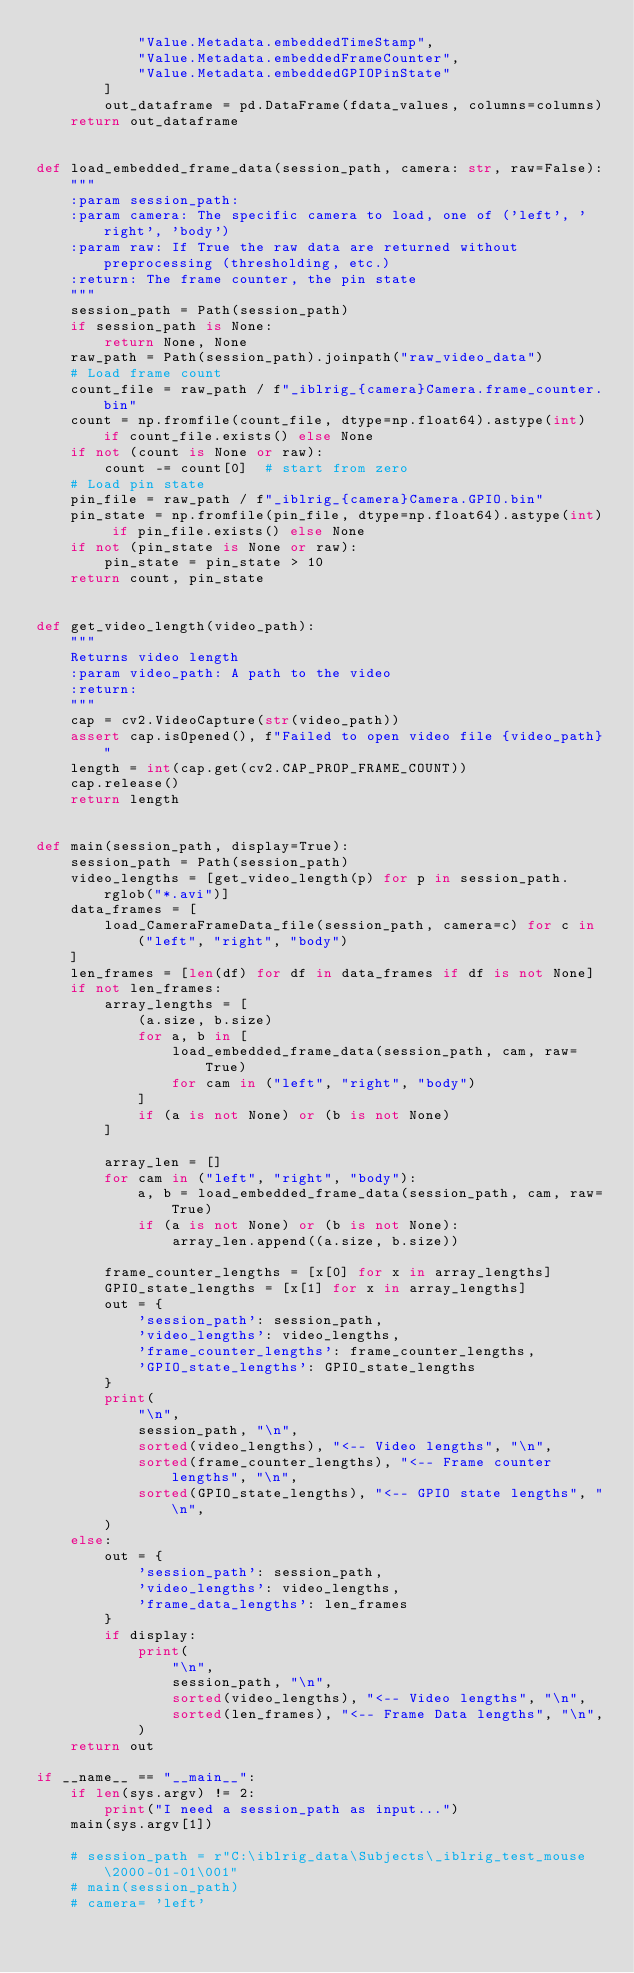<code> <loc_0><loc_0><loc_500><loc_500><_Python_>            "Value.Metadata.embeddedTimeStamp",
            "Value.Metadata.embeddedFrameCounter",
            "Value.Metadata.embeddedGPIOPinState"
        ]
        out_dataframe = pd.DataFrame(fdata_values, columns=columns)
    return out_dataframe


def load_embedded_frame_data(session_path, camera: str, raw=False):
    """
    :param session_path:
    :param camera: The specific camera to load, one of ('left', 'right', 'body')
    :param raw: If True the raw data are returned without preprocessing (thresholding, etc.)
    :return: The frame counter, the pin state
    """
    session_path = Path(session_path)
    if session_path is None:
        return None, None
    raw_path = Path(session_path).joinpath("raw_video_data")
    # Load frame count
    count_file = raw_path / f"_iblrig_{camera}Camera.frame_counter.bin"
    count = np.fromfile(count_file, dtype=np.float64).astype(int) if count_file.exists() else None
    if not (count is None or raw):
        count -= count[0]  # start from zero
    # Load pin state
    pin_file = raw_path / f"_iblrig_{camera}Camera.GPIO.bin"
    pin_state = np.fromfile(pin_file, dtype=np.float64).astype(int) if pin_file.exists() else None
    if not (pin_state is None or raw):
        pin_state = pin_state > 10
    return count, pin_state


def get_video_length(video_path):
    """
    Returns video length
    :param video_path: A path to the video
    :return:
    """
    cap = cv2.VideoCapture(str(video_path))
    assert cap.isOpened(), f"Failed to open video file {video_path}"
    length = int(cap.get(cv2.CAP_PROP_FRAME_COUNT))
    cap.release()
    return length


def main(session_path, display=True):
    session_path = Path(session_path)
    video_lengths = [get_video_length(p) for p in session_path.rglob("*.avi")]
    data_frames = [
        load_CameraFrameData_file(session_path, camera=c) for c in ("left", "right", "body")
    ]
    len_frames = [len(df) for df in data_frames if df is not None]
    if not len_frames:
        array_lengths = [
            (a.size, b.size)
            for a, b in [
                load_embedded_frame_data(session_path, cam, raw=True)
                for cam in ("left", "right", "body")
            ]
            if (a is not None) or (b is not None)
        ]

        array_len = []
        for cam in ("left", "right", "body"):
            a, b = load_embedded_frame_data(session_path, cam, raw=True)
            if (a is not None) or (b is not None):
                array_len.append((a.size, b.size))

        frame_counter_lengths = [x[0] for x in array_lengths]
        GPIO_state_lengths = [x[1] for x in array_lengths]
        out = {
            'session_path': session_path,
            'video_lengths': video_lengths,
            'frame_counter_lengths': frame_counter_lengths,
            'GPIO_state_lengths': GPIO_state_lengths
        }
        print(
            "\n",
            session_path, "\n",
            sorted(video_lengths), "<-- Video lengths", "\n",
            sorted(frame_counter_lengths), "<-- Frame counter lengths", "\n",
            sorted(GPIO_state_lengths), "<-- GPIO state lengths", "\n",
        )
    else:
        out = {
            'session_path': session_path,
            'video_lengths': video_lengths,
            'frame_data_lengths': len_frames
        }
        if display:
            print(
                "\n",
                session_path, "\n",
                sorted(video_lengths), "<-- Video lengths", "\n",
                sorted(len_frames), "<-- Frame Data lengths", "\n",
            )
    return out

if __name__ == "__main__":
    if len(sys.argv) != 2:
        print("I need a session_path as input...")
    main(sys.argv[1])

    # session_path = r"C:\iblrig_data\Subjects\_iblrig_test_mouse\2000-01-01\001"
    # main(session_path)
    # camera= 'left'
</code> 